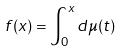<formula> <loc_0><loc_0><loc_500><loc_500>f ( x ) = \int _ { 0 } ^ { x } d \mu ( t )</formula> 